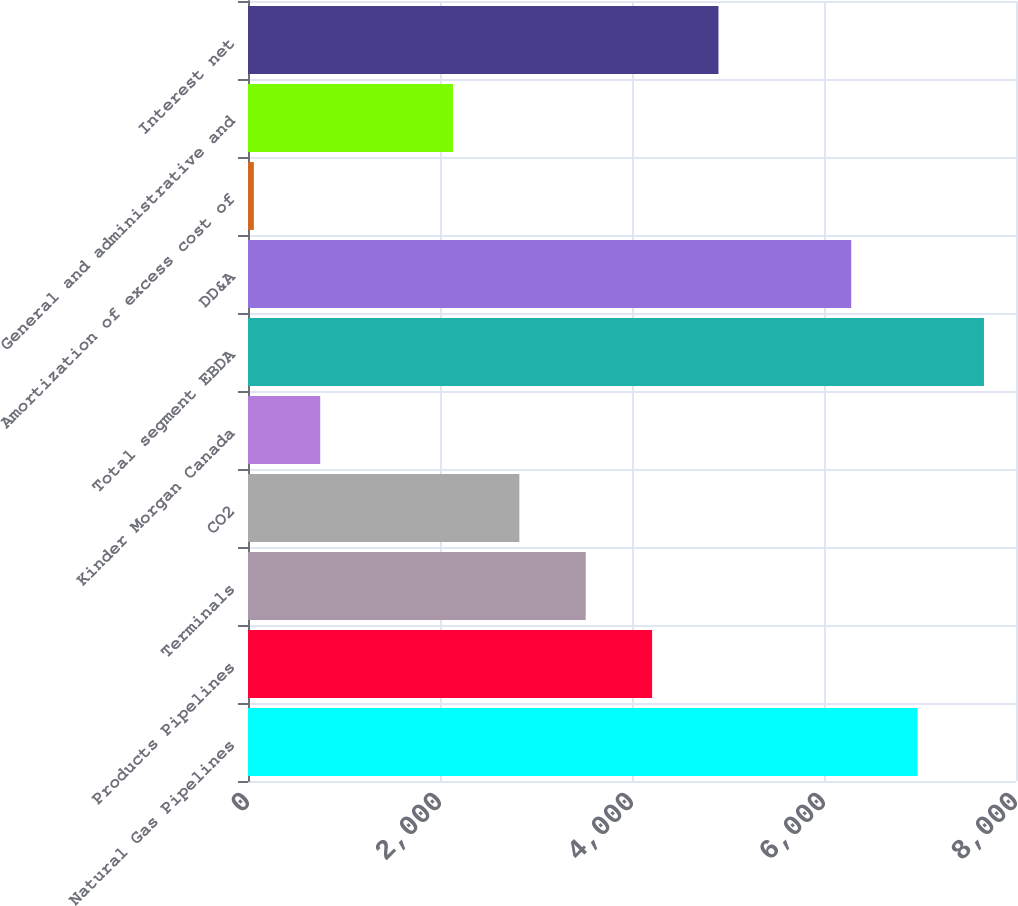Convert chart to OTSL. <chart><loc_0><loc_0><loc_500><loc_500><bar_chart><fcel>Natural Gas Pipelines<fcel>Products Pipelines<fcel>Terminals<fcel>CO2<fcel>Kinder Morgan Canada<fcel>Total segment EBDA<fcel>DD&A<fcel>Amortization of excess cost of<fcel>General and administrative and<fcel>Interest net<nl><fcel>6975<fcel>4209.4<fcel>3518<fcel>2826.6<fcel>752.4<fcel>7666.4<fcel>6283.6<fcel>61<fcel>2135.2<fcel>4900.8<nl></chart> 